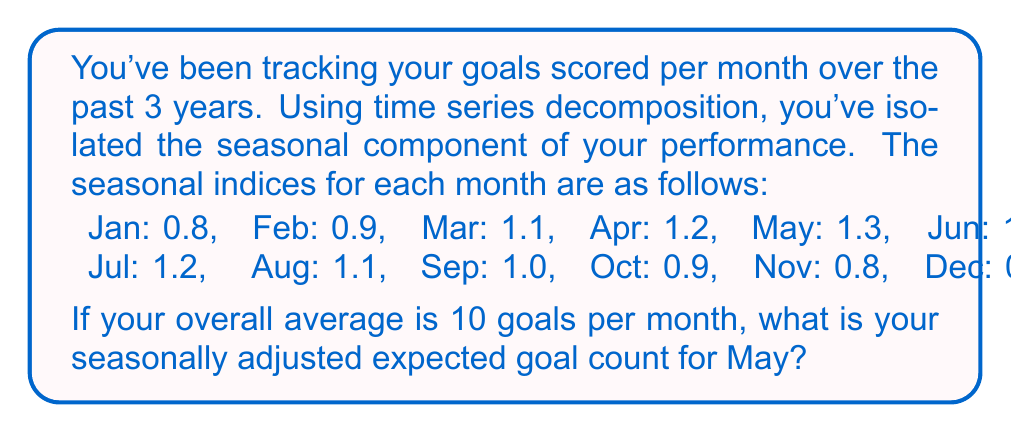Can you solve this math problem? To solve this problem, we need to understand the concept of seasonal decomposition and how to use seasonal indices. Here's a step-by-step explanation:

1) In time series decomposition, we typically break down a series into three components:
   $$ Y_t = T_t \times S_t \times I_t $$
   Where $Y_t$ is the observed value, $T_t$ is the trend component, $S_t$ is the seasonal component, and $I_t$ is the irregular component.

2) The seasonal indices represent the $S_t$ component. An index above 1 indicates a season with above-average performance, while below 1 indicates below-average performance.

3) The overall average of 10 goals per month represents the trend component $T_t$ (assuming no long-term trend).

4) To find the seasonally adjusted value, we divide the trend by the seasonal index:
   $$ \text{Seasonally Adjusted Value} = \frac{T_t}{S_t} $$

5) For May, the seasonal index is 1.3.

6) Therefore, the seasonally adjusted expected goal count for May is:
   $$ \text{Seasonally Adjusted Value} = \frac{10}{1.3} \approx 7.69 $$

This means that while your average is 10 goals per month, in May you would typically score more due to seasonal factors. The seasonally adjusted value of 7.69 represents what your performance would be if these seasonal factors were removed.
Answer: 7.69 goals 